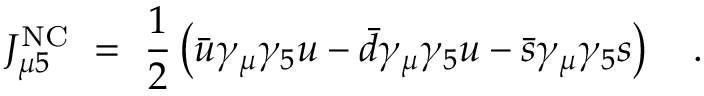Convert formula to latex. <formula><loc_0><loc_0><loc_500><loc_500>J _ { \mu 5 } ^ { N C } \ = \ { \frac { 1 } { 2 } } \left ( \bar { u } \gamma _ { \mu } \gamma _ { 5 } u - \bar { d } \gamma _ { \mu } \gamma _ { 5 } u - \bar { s } \gamma _ { \mu } \gamma _ { 5 } s \right ) .</formula> 